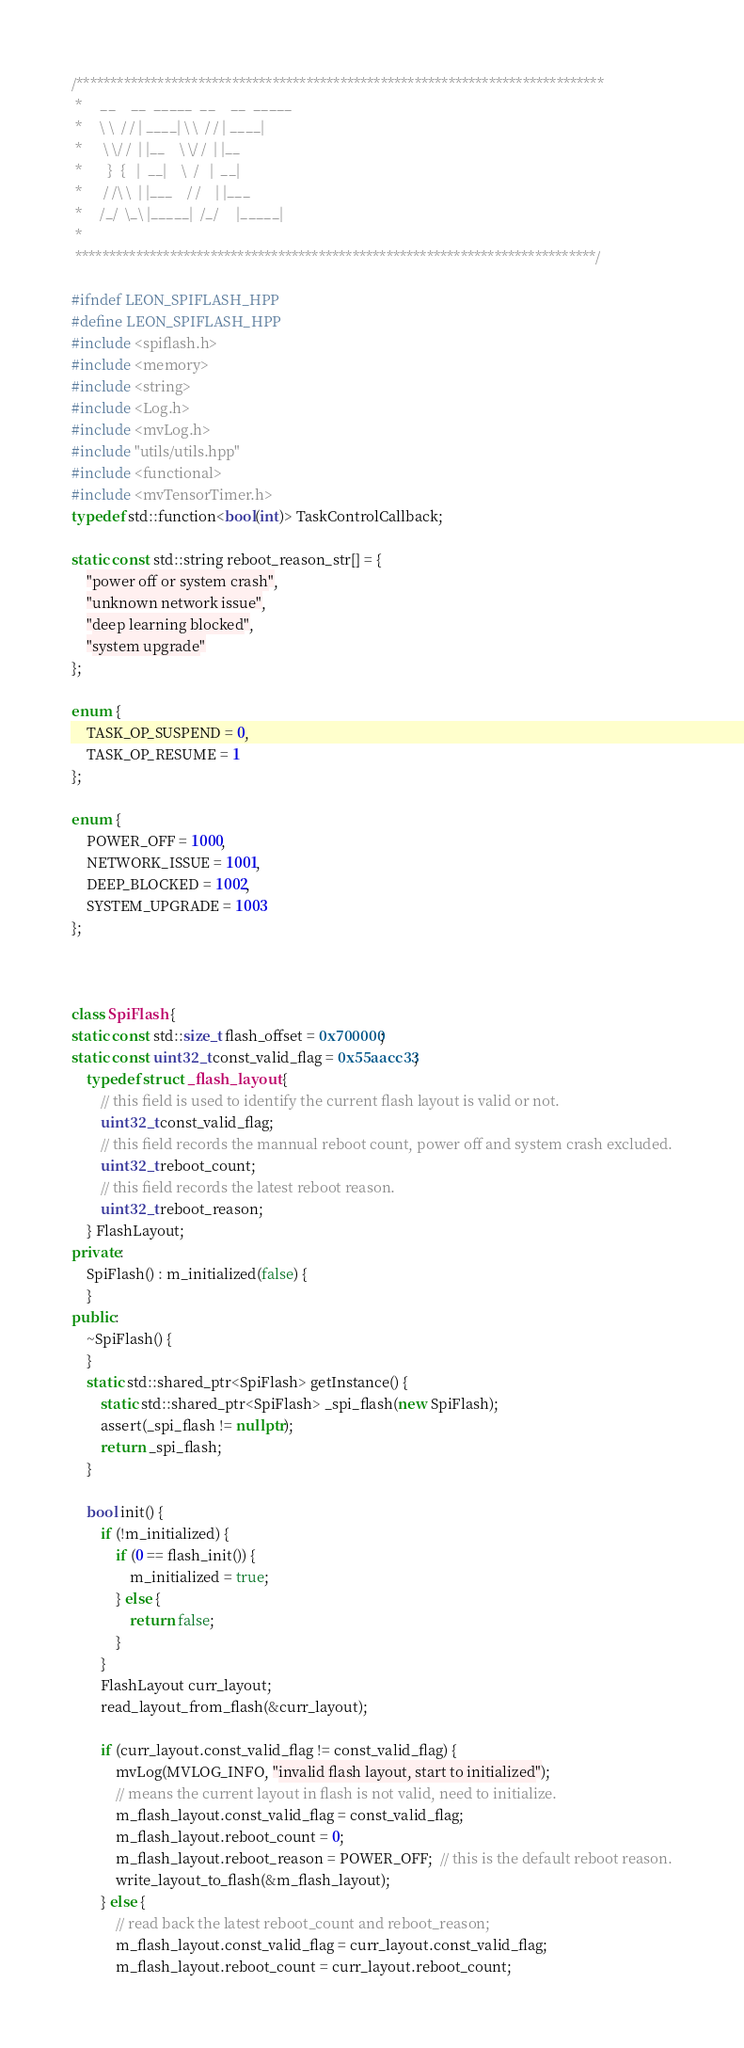Convert code to text. <code><loc_0><loc_0><loc_500><loc_500><_C++_>/******************************************************************************
 *     __    __  _____  __    __  _____
 *     \ \  / / | ____| \ \  / / | ____|
 *      \ \/ /  | |__    \ \/ /  | |__
 *       }  {   |  __|    \  /   |  __|
 *      / /\ \  | |___    / /    | |___
 *     /_/  \_\ |_____|  /_/     |_____|
 *
 *****************************************************************************/

#ifndef LEON_SPIFLASH_HPP
#define LEON_SPIFLASH_HPP
#include <spiflash.h>
#include <memory>
#include <string>
#include <Log.h>
#include <mvLog.h>
#include "utils/utils.hpp"
#include <functional>
#include <mvTensorTimer.h>
typedef std::function<bool(int)> TaskControlCallback;

static const std::string reboot_reason_str[] = {
    "power off or system crash",
    "unknown network issue",
    "deep learning blocked",
    "system upgrade"
};

enum {
    TASK_OP_SUSPEND = 0,
    TASK_OP_RESUME = 1
};

enum {
    POWER_OFF = 1000,
    NETWORK_ISSUE = 1001,
    DEEP_BLOCKED = 1002,
    SYSTEM_UPGRADE = 1003
};



class SpiFlash {
static const std::size_t flash_offset = 0x700000;
static const uint32_t const_valid_flag = 0x55aacc33;
    typedef struct _flash_layout {
        // this field is used to identify the current flash layout is valid or not.
        uint32_t const_valid_flag;
        // this field records the mannual reboot count, power off and system crash excluded.
        uint32_t reboot_count;
        // this field records the latest reboot reason.
        uint32_t reboot_reason;
    } FlashLayout;
private:
    SpiFlash() : m_initialized(false) {
    }
public:
    ~SpiFlash() {
    }
    static std::shared_ptr<SpiFlash> getInstance() {
        static std::shared_ptr<SpiFlash> _spi_flash(new SpiFlash);
        assert(_spi_flash != nullptr);
        return _spi_flash;
    }

    bool init() {
        if (!m_initialized) {
            if (0 == flash_init()) {
                m_initialized = true;
            } else {
                return false;
            }
        }
        FlashLayout curr_layout;
        read_layout_from_flash(&curr_layout);

        if (curr_layout.const_valid_flag != const_valid_flag) {
            mvLog(MVLOG_INFO, "invalid flash layout, start to initialized");
            // means the current layout in flash is not valid, need to initialize.
            m_flash_layout.const_valid_flag = const_valid_flag;
            m_flash_layout.reboot_count = 0;
            m_flash_layout.reboot_reason = POWER_OFF;  // this is the default reboot reason.
            write_layout_to_flash(&m_flash_layout);
        } else {
            // read back the latest reboot_count and reboot_reason;
            m_flash_layout.const_valid_flag = curr_layout.const_valid_flag;
            m_flash_layout.reboot_count = curr_layout.reboot_count;</code> 